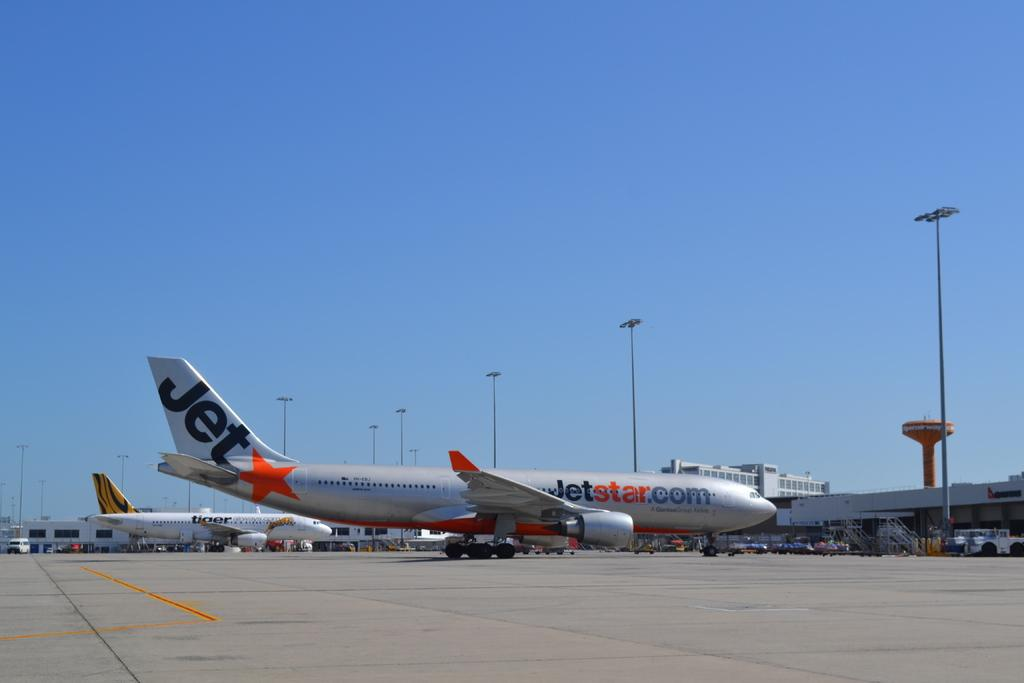<image>
Render a clear and concise summary of the photo. A plane at an airport has the word Jet on its tail. 